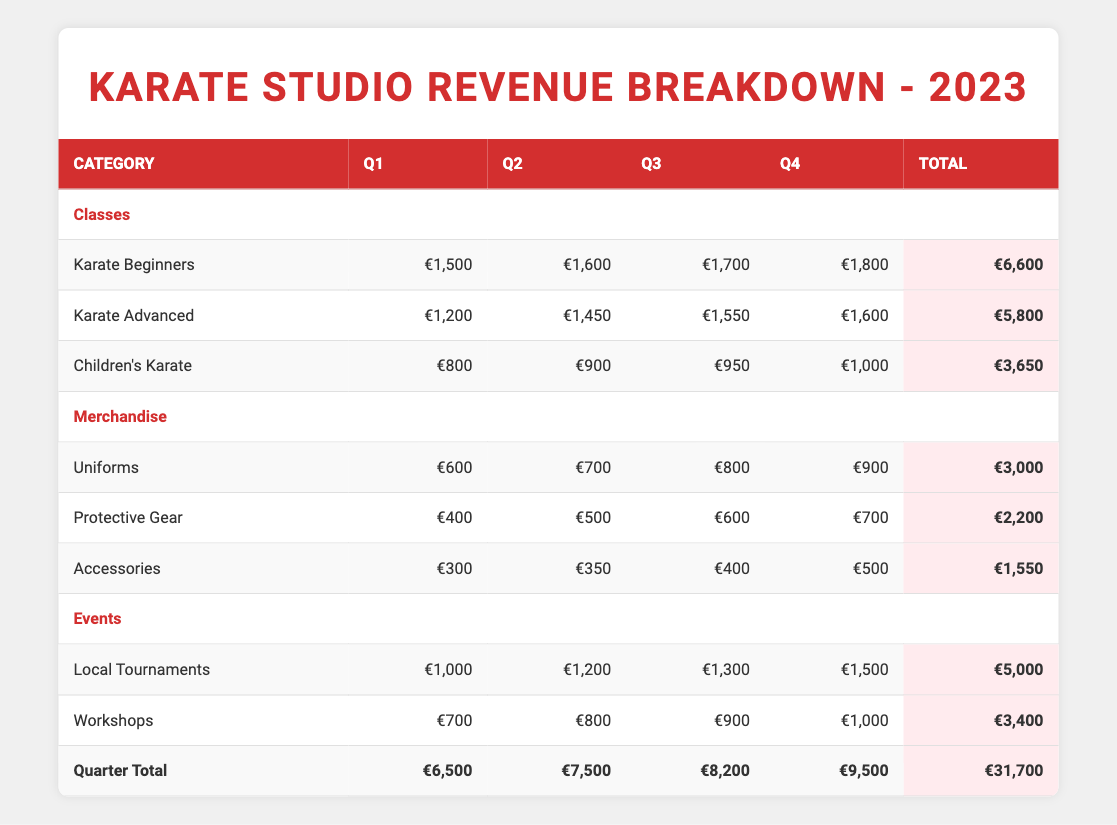What was the total revenue from Classes in Q3? To find the total revenue from Classes in Q3, we need to add the revenue from each category under Classes for Q3: Karate Beginners (€1,700) + Karate Advanced (€1,550) + Children's Karate (€950) = €4,200.
Answer: 4200 Which quarter had the highest total revenue? Looking at the total revenue for each quarter: Q1 (€6,500), Q2 (€7,500), Q3 (€8,200), and Q4 (€9,500), the highest total is in Q4, which generated €9,500.
Answer: Q4 What was the increase in revenue from Local Tournaments from Q1 to Q4? The revenue from Local Tournaments in Q1 is €1,000 and in Q4 is €1,500. To find the increase, subtract the Q1 revenue from Q4 revenue: €1,500 - €1,000 = €500.
Answer: 500 Did total revenue from Merchandise increase every quarter? To determine if the revenue from Merchandise increased every quarter, we examine the totals: Q1 (€1,300), Q2 (€1,550), Q3 (€1,800), and Q4 (€2,100). All values increased from Q1 to Q2, Q2 to Q3, and Q3 to Q4, which confirms the increase.
Answer: Yes What is the average revenue from Workshops across all quarters? To find the average revenue from Workshops, we sum the revenue for each quarter: Q1 (€700), Q2 (€800), Q3 (€900), Q4 (€1,000). Total = €700 + €800 + €900 + €1,000 = €3,400. Then, divide by 4 (the number of quarters): €3,400 / 4 = €850.
Answer: 850 Which class generated the most revenue in total for the year? To find which class generated the most revenue overall, sum the revenue from each class across all quarters. Karate Beginners: €6,600, Karate Advanced: €5,800, Children's Karate: €3,650. Karate Beginners has the highest total revenue of €6,600.
Answer: Karate Beginners What percentage of the total revenue for Q2 came from Events? Total revenue for Q2 is €7,500 and the revenue from Events in Q2 is €2,000 (Local Tournaments €1,200 + Workshops €800). To find the percentage, divide the Events revenue by total revenue: (€2,000 / €7,500) * 100 = 26.67%.
Answer: 26.67% How much more revenue did Karate Advanced generate compared to Children's Karate in Q1? Karate Advanced revenue in Q1 is €1,200 and Children's Karate revenue in Q1 is €800. To find the difference, subtract the amount for Children's Karate from Karate Advanced: €1,200 - €800 = €400.
Answer: 400 What was the total revenue from all sources in Q3? To calculate the total revenue from all sources in Q3, sum the revenue from Classes (€4,200), Merchandise (€1,800), and Events (€2,200): €4,200 + €1,800 + €2,200 = €8,200.
Answer: 8200 